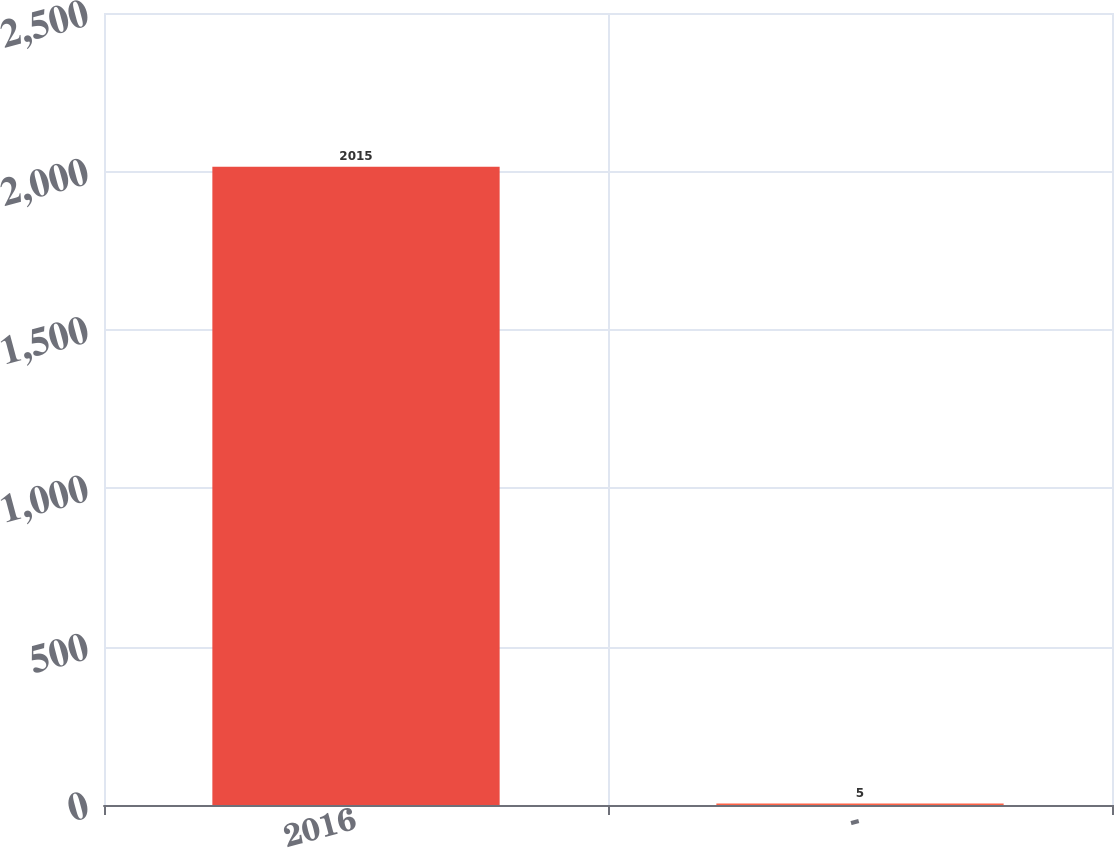Convert chart. <chart><loc_0><loc_0><loc_500><loc_500><bar_chart><fcel>2016<fcel>-<nl><fcel>2015<fcel>5<nl></chart> 